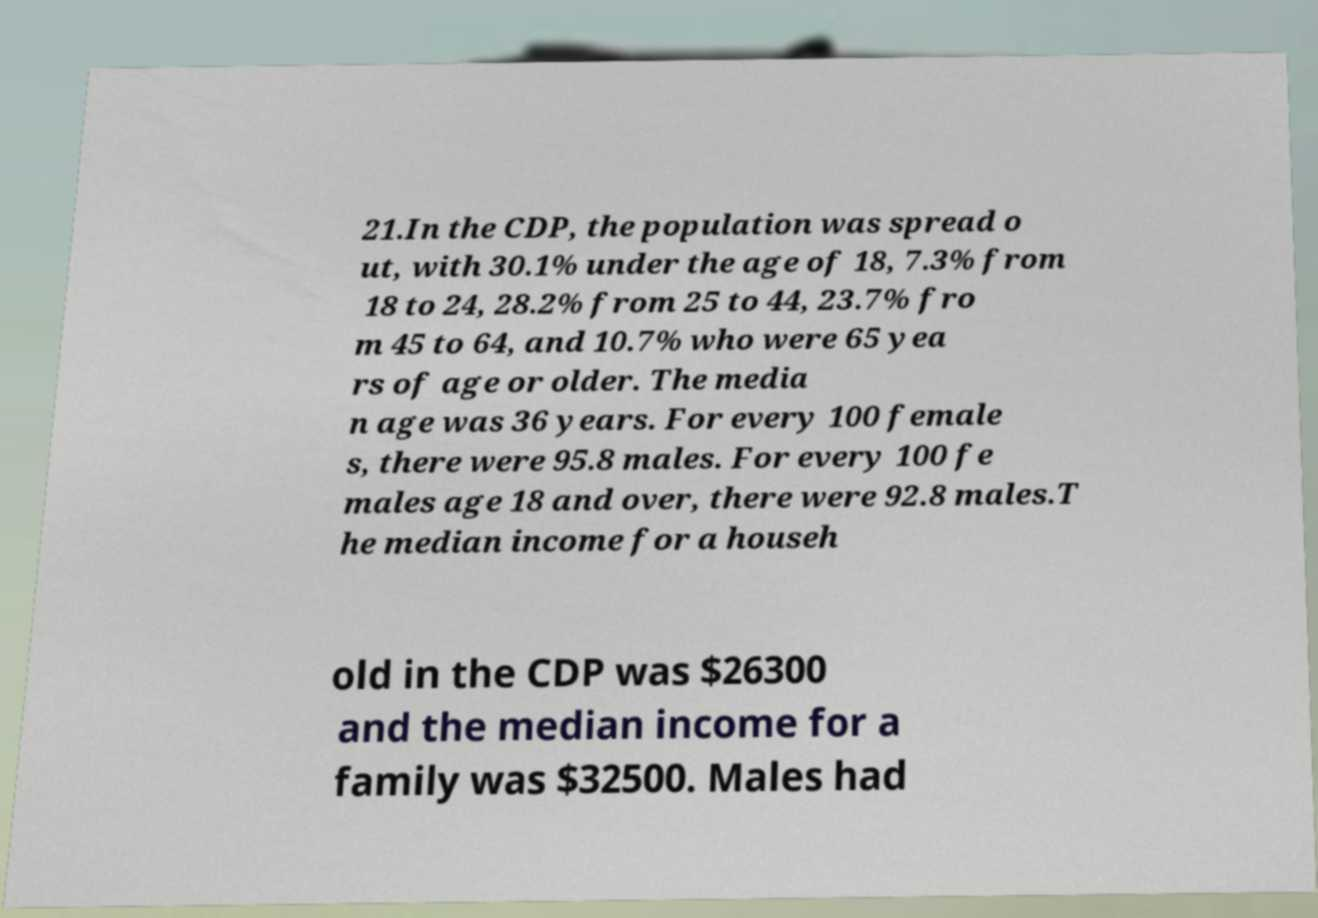Please read and relay the text visible in this image. What does it say? 21.In the CDP, the population was spread o ut, with 30.1% under the age of 18, 7.3% from 18 to 24, 28.2% from 25 to 44, 23.7% fro m 45 to 64, and 10.7% who were 65 yea rs of age or older. The media n age was 36 years. For every 100 female s, there were 95.8 males. For every 100 fe males age 18 and over, there were 92.8 males.T he median income for a househ old in the CDP was $26300 and the median income for a family was $32500. Males had 